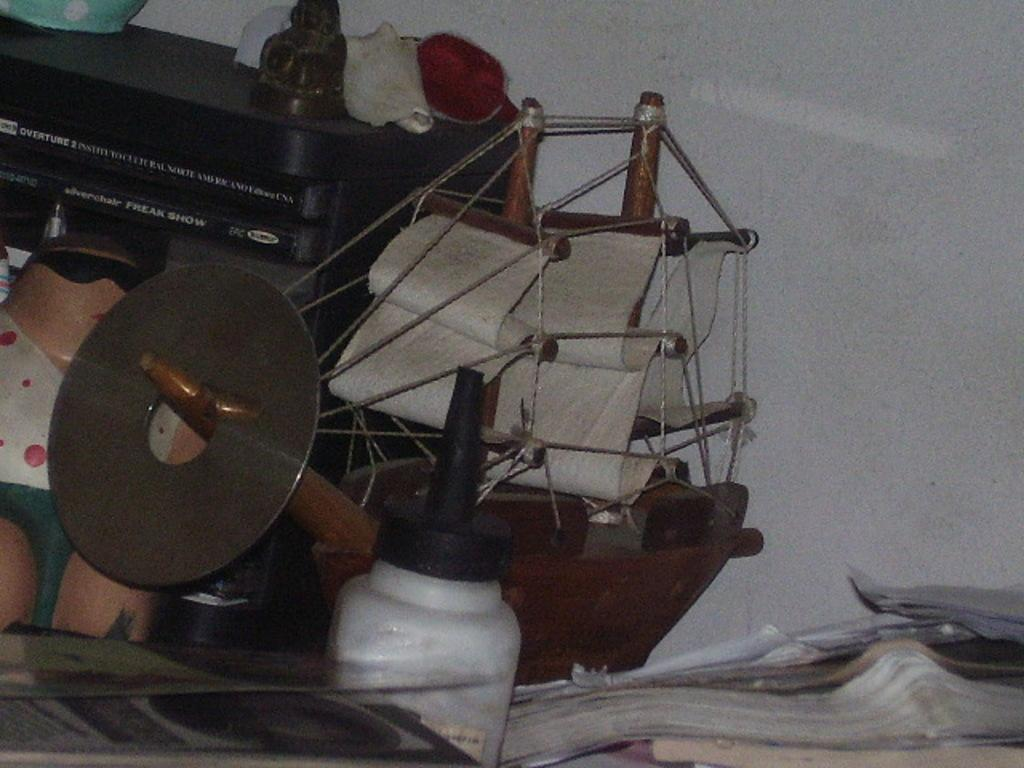What object can be seen in the image that is typically used for holding liquids? There is a bottle in the image. What type of items are visible in the image that are often used for learning or entertainment? There are books and toys in the image, including a toy boat. Can you describe any other objects present in the image? There are some other items in the image, but their specific details are not mentioned in the facts. What can be seen in the background of the image? There is a wall in the background of the image. What type of horn can be seen on the toy boat in the image? There is no horn present on the toy boat in the image. How many legs does the toy boat have in the image? Toys, including toy boats, do not have legs, as they are inanimate objects. 